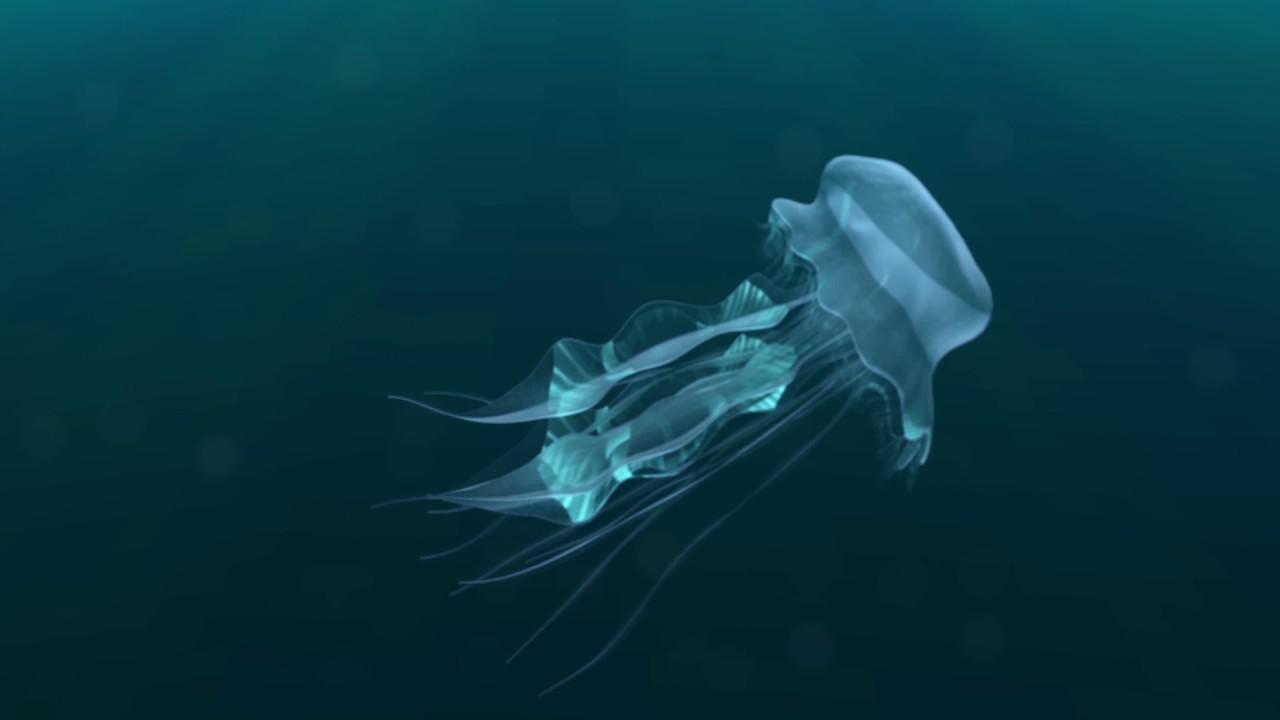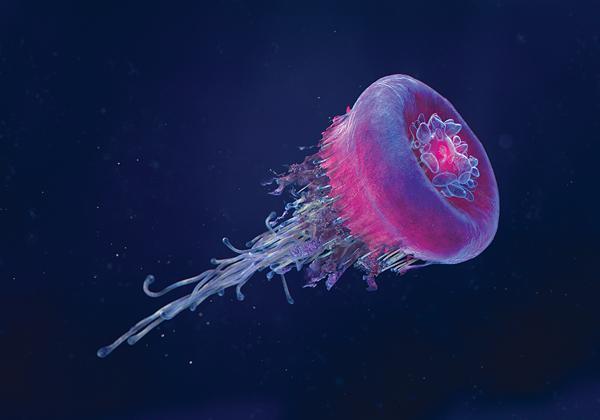The first image is the image on the left, the second image is the image on the right. For the images displayed, is the sentence "There are less than 9 jellyfish." factually correct? Answer yes or no. Yes. The first image is the image on the left, the second image is the image on the right. Given the left and right images, does the statement "One image features a translucent blue jellyfish moving diagonally to the right, with tentacles trailing behind it." hold true? Answer yes or no. Yes. 